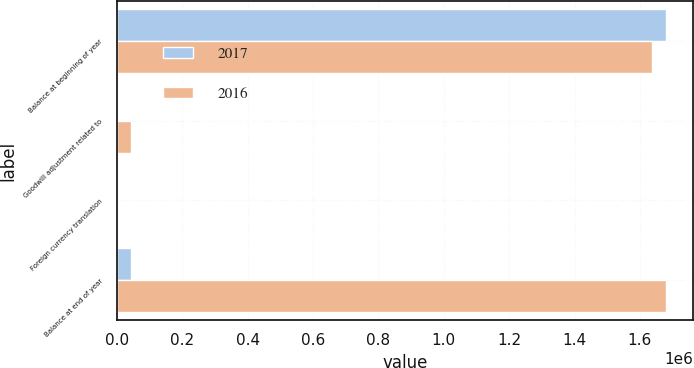Convert chart. <chart><loc_0><loc_0><loc_500><loc_500><stacked_bar_chart><ecel><fcel>Balance at beginning of year<fcel>Goodwill adjustment related to<fcel>Foreign currency translation<fcel>Balance at end of year<nl><fcel>2017<fcel>1.67912e+06<fcel>4198<fcel>1869<fcel>44046<nl><fcel>2016<fcel>1.63653e+06<fcel>44046<fcel>1456<fcel>1.67912e+06<nl></chart> 